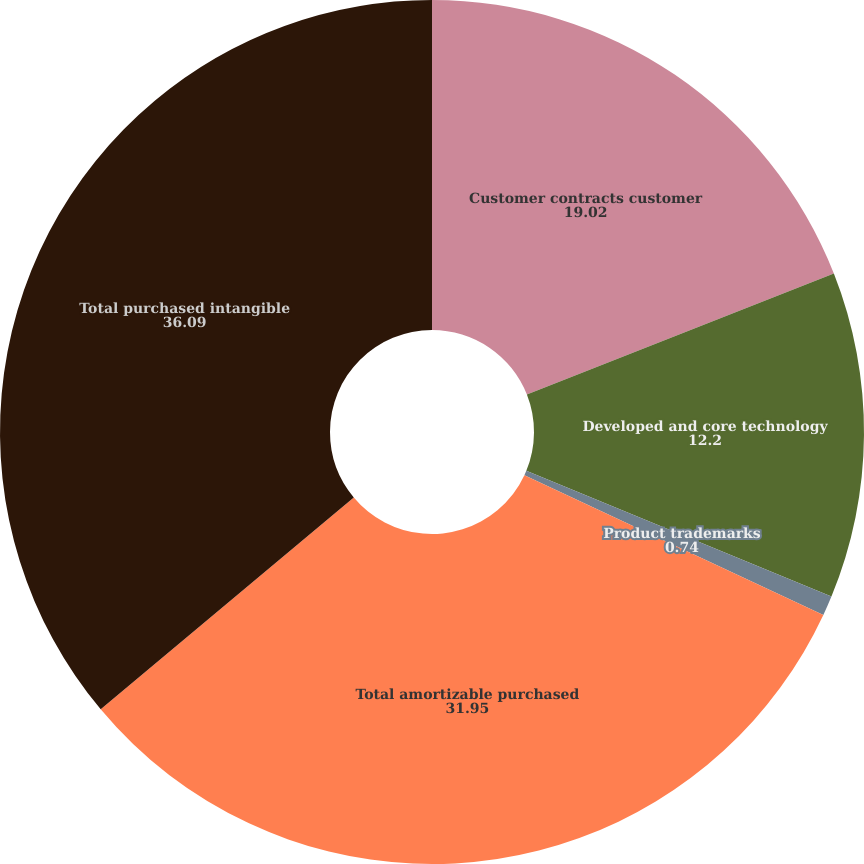<chart> <loc_0><loc_0><loc_500><loc_500><pie_chart><fcel>Customer contracts customer<fcel>Developed and core technology<fcel>Product trademarks<fcel>Total amortizable purchased<fcel>Total purchased intangible<nl><fcel>19.02%<fcel>12.2%<fcel>0.74%<fcel>31.95%<fcel>36.09%<nl></chart> 